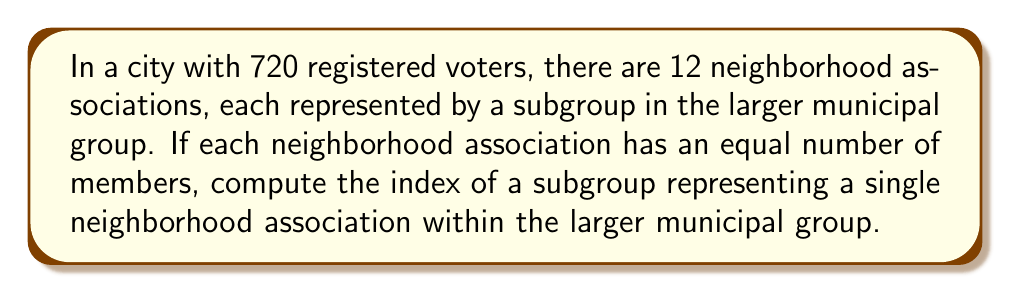Provide a solution to this math problem. Let's approach this step-by-step:

1) First, we need to understand what the index of a subgroup means. The index of a subgroup H in a group G, denoted [G:H], is the number of distinct left cosets of H in G. It's also equal to the number of right cosets, and can be calculated as:

   $$ [G:H] = \frac{|G|}{|H|} $$

   where |G| is the order (size) of the larger group and |H| is the order of the subgroup.

2) In this problem, G is the entire municipal group (all registered voters), and H is a single neighborhood association.

3) We're given that |G| = 720 (total registered voters).

4) We're told there are 12 neighborhood associations of equal size. To find |H|, we divide the total number of voters by the number of associations:

   $$ |H| = \frac{720}{12} = 60 $$

5) Now we can calculate the index:

   $$ [G:H] = \frac{|G|}{|H|} = \frac{720}{60} = 12 $$

This result makes intuitive sense in the context of urban planning: the index of 12 represents the number of distinct neighborhood associations within the larger municipal group.
Answer: The index of a subgroup representing a single neighborhood association within the larger municipal group is 12. 